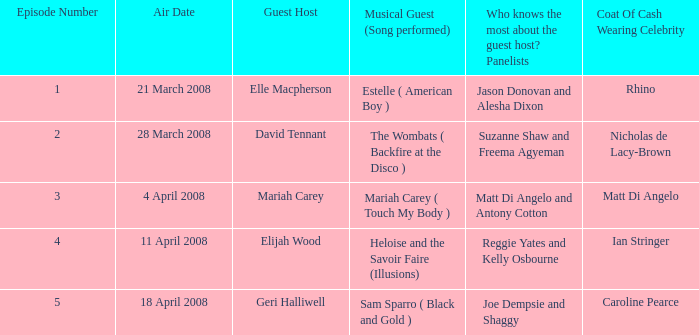Identify the total count of coat of cash donning stars with panelists matt di angelo and antony cotton. 1.0. 